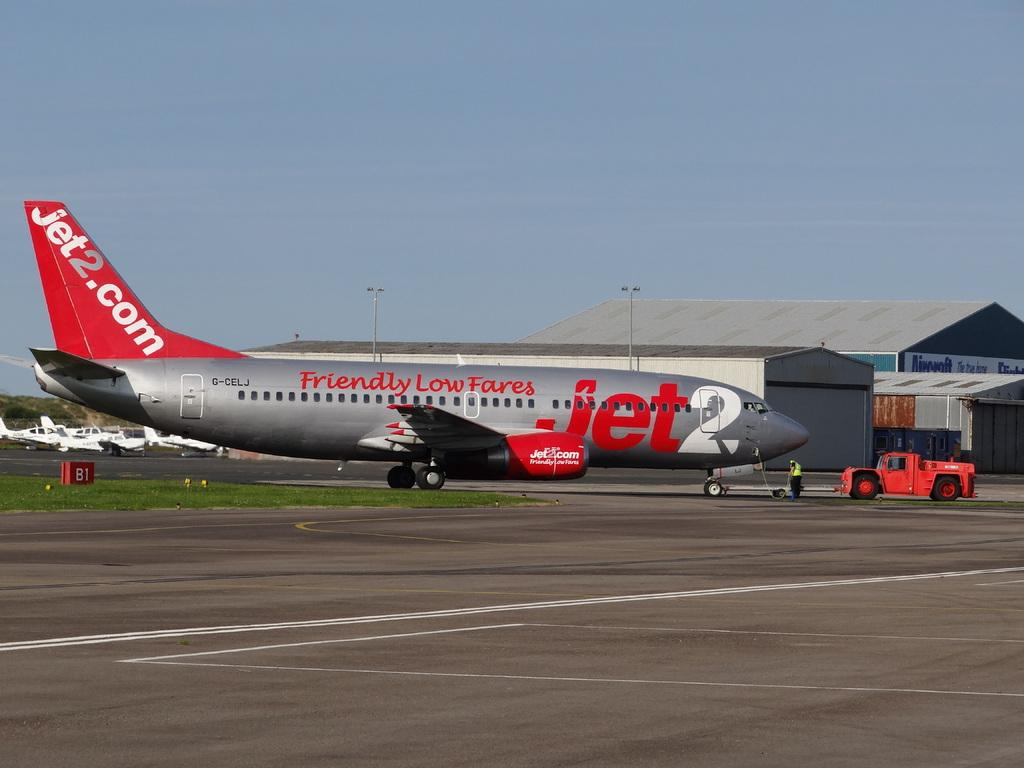<image>
Present a compact description of the photo's key features. a plane on a runway with Jet2.com on the tail 